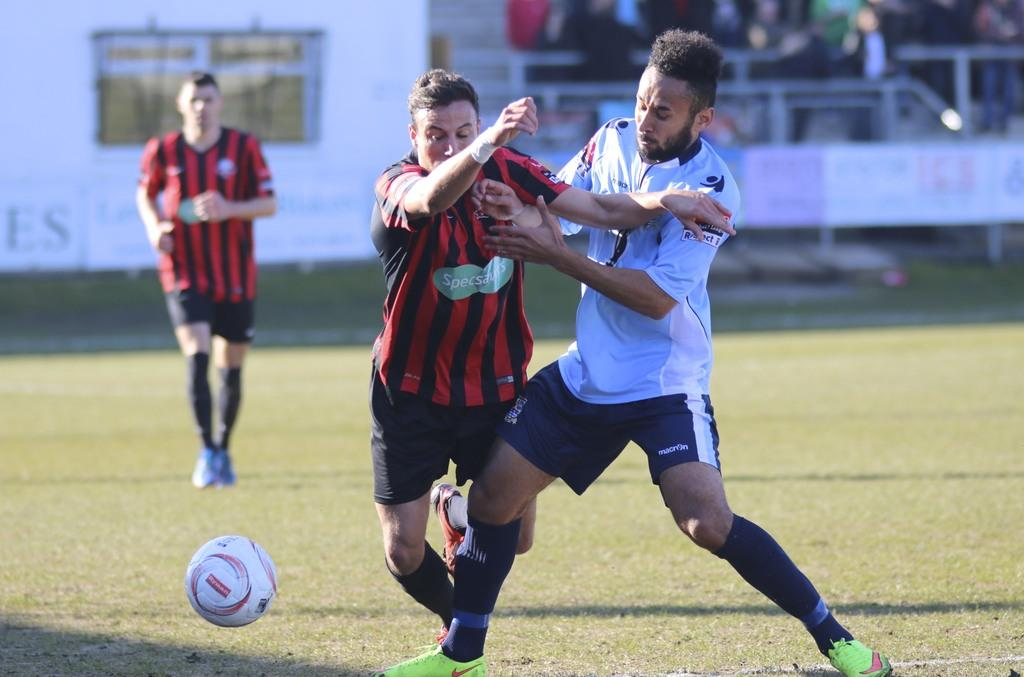How many people are in the image? There are three persons in the image. What are the persons doing in the image? The persons are standing and playing with a ball. What can be seen in the background of the image? There are boards and iron rods in the background of the image. Are there any other people visible in the image? Yes, there is a group of people in the background of the image. Can you see a snail crawling on the ball in the image? No, there is no snail present in the image. What type of patch is on the sofa in the image? There is no sofa present in the image. 